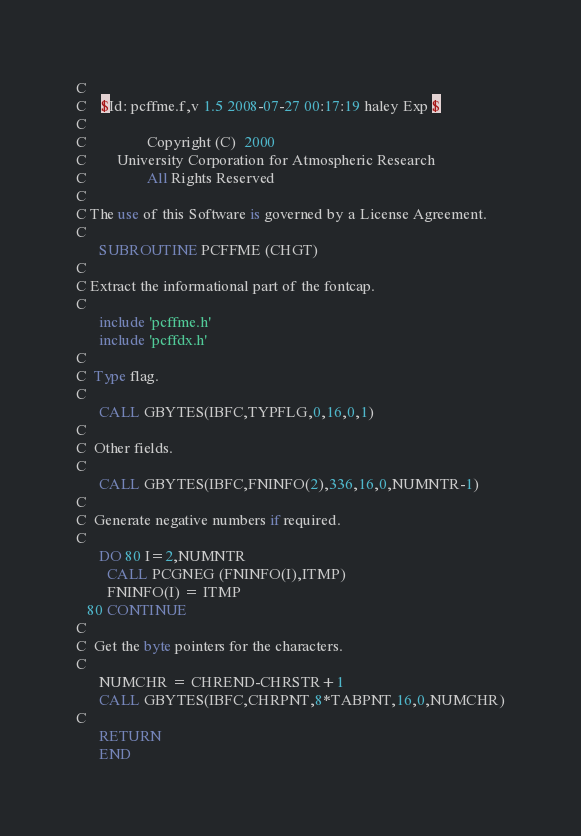Convert code to text. <code><loc_0><loc_0><loc_500><loc_500><_FORTRAN_>C
C	$Id: pcffme.f,v 1.5 2008-07-27 00:17:19 haley Exp $
C                                                                      
C                Copyright (C)  2000
C        University Corporation for Atmospheric Research
C                All Rights Reserved
C
C The use of this Software is governed by a License Agreement.
C
      SUBROUTINE PCFFME (CHGT)
C
C Extract the informational part of the fontcap.
C
      include 'pcffme.h'
      include 'pcffdx.h'
C
C  Type flag.
C
      CALL GBYTES(IBFC,TYPFLG,0,16,0,1)
C
C  Other fields.
C
      CALL GBYTES(IBFC,FNINFO(2),336,16,0,NUMNTR-1)
C
C  Generate negative numbers if required.
C
      DO 80 I=2,NUMNTR
        CALL PCGNEG (FNINFO(I),ITMP)
        FNINFO(I) = ITMP
   80 CONTINUE
C
C  Get the byte pointers for the characters.
C
      NUMCHR = CHREND-CHRSTR+1
      CALL GBYTES(IBFC,CHRPNT,8*TABPNT,16,0,NUMCHR)
C
      RETURN
      END
</code> 